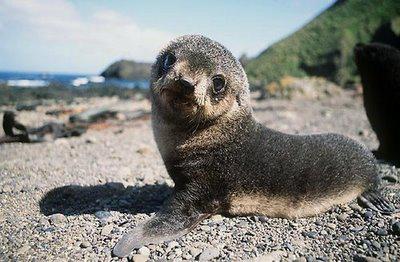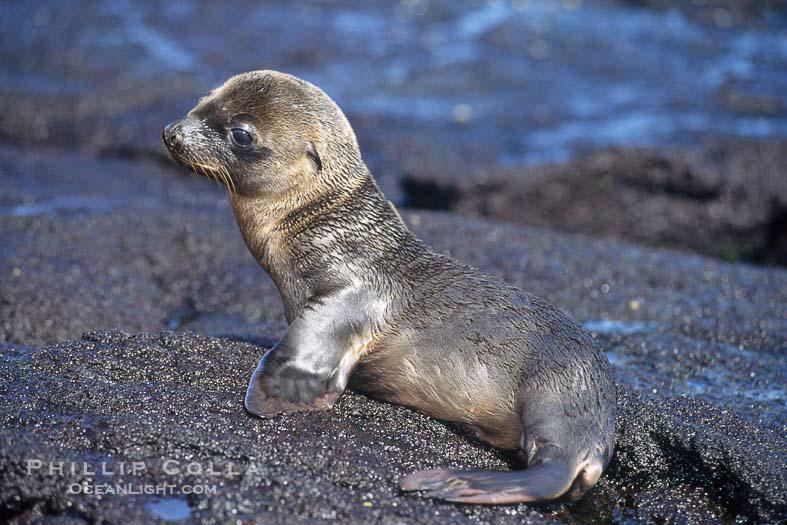The first image is the image on the left, the second image is the image on the right. Analyze the images presented: Is the assertion "Two seals are on a sandy surface in the image on the left." valid? Answer yes or no. No. 